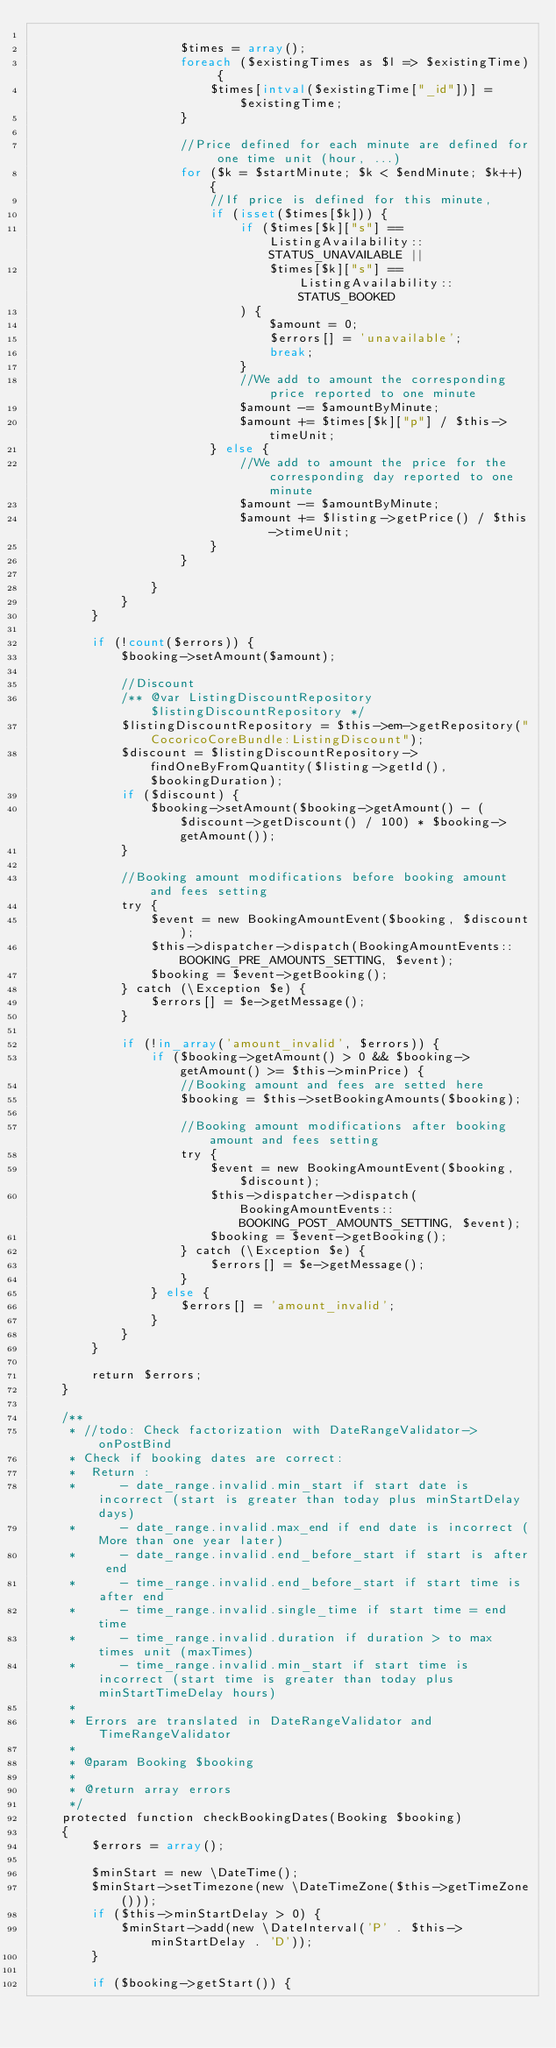<code> <loc_0><loc_0><loc_500><loc_500><_PHP_>
                    $times = array();
                    foreach ($existingTimes as $l => $existingTime) {
                        $times[intval($existingTime["_id"])] = $existingTime;
                    }

                    //Price defined for each minute are defined for one time unit (hour, ...)
                    for ($k = $startMinute; $k < $endMinute; $k++) {
                        //If price is defined for this minute,
                        if (isset($times[$k])) {
                            if ($times[$k]["s"] == ListingAvailability::STATUS_UNAVAILABLE ||
                                $times[$k]["s"] == ListingAvailability::STATUS_BOOKED
                            ) {
                                $amount = 0;
                                $errors[] = 'unavailable';
                                break;
                            }
                            //We add to amount the corresponding price reported to one minute
                            $amount -= $amountByMinute;
                            $amount += $times[$k]["p"] / $this->timeUnit;
                        } else {
                            //We add to amount the price for the corresponding day reported to one minute
                            $amount -= $amountByMinute;
                            $amount += $listing->getPrice() / $this->timeUnit;
                        }
                    }

                }
            }
        }

        if (!count($errors)) {
            $booking->setAmount($amount);

            //Discount
            /** @var ListingDiscountRepository $listingDiscountRepository */
            $listingDiscountRepository = $this->em->getRepository("CocoricoCoreBundle:ListingDiscount");
            $discount = $listingDiscountRepository->findOneByFromQuantity($listing->getId(), $bookingDuration);
            if ($discount) {
                $booking->setAmount($booking->getAmount() - ($discount->getDiscount() / 100) * $booking->getAmount());
            }

            //Booking amount modifications before booking amount and fees setting
            try {
                $event = new BookingAmountEvent($booking, $discount);
                $this->dispatcher->dispatch(BookingAmountEvents::BOOKING_PRE_AMOUNTS_SETTING, $event);
                $booking = $event->getBooking();
            } catch (\Exception $e) {
                $errors[] = $e->getMessage();
            }

            if (!in_array('amount_invalid', $errors)) {
                if ($booking->getAmount() > 0 && $booking->getAmount() >= $this->minPrice) {
                    //Booking amount and fees are setted here
                    $booking = $this->setBookingAmounts($booking);

                    //Booking amount modifications after booking amount and fees setting
                    try {
                        $event = new BookingAmountEvent($booking, $discount);
                        $this->dispatcher->dispatch(BookingAmountEvents::BOOKING_POST_AMOUNTS_SETTING, $event);
                        $booking = $event->getBooking();
                    } catch (\Exception $e) {
                        $errors[] = $e->getMessage();
                    }
                } else {
                    $errors[] = 'amount_invalid';
                }
            }
        }

        return $errors;
    }

    /**
     * //todo: Check factorization with DateRangeValidator->onPostBind
     * Check if booking dates are correct:
     *  Return :
     *      - date_range.invalid.min_start if start date is incorrect (start is greater than today plus minStartDelay days)
     *      - date_range.invalid.max_end if end date is incorrect (More than one year later)
     *      - date_range.invalid.end_before_start if start is after end
     *      - time_range.invalid.end_before_start if start time is after end
     *      - time_range.invalid.single_time if start time = end time
     *      - time_range.invalid.duration if duration > to max times unit (maxTimes)
     *      - time_range.invalid.min_start if start time is incorrect (start time is greater than today plus minStartTimeDelay hours)
     *
     * Errors are translated in DateRangeValidator and TimeRangeValidator
     *
     * @param Booking $booking
     *
     * @return array errors
     */
    protected function checkBookingDates(Booking $booking)
    {
        $errors = array();

        $minStart = new \DateTime();
        $minStart->setTimezone(new \DateTimeZone($this->getTimeZone()));
        if ($this->minStartDelay > 0) {
            $minStart->add(new \DateInterval('P' . $this->minStartDelay . 'D'));
        }

        if ($booking->getStart()) {</code> 